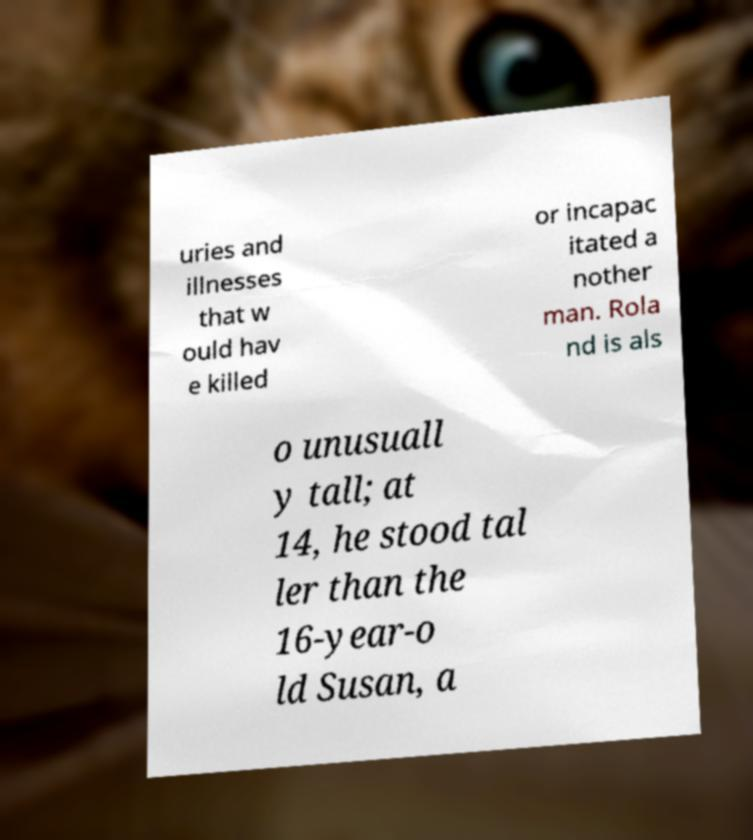There's text embedded in this image that I need extracted. Can you transcribe it verbatim? uries and illnesses that w ould hav e killed or incapac itated a nother man. Rola nd is als o unusuall y tall; at 14, he stood tal ler than the 16-year-o ld Susan, a 